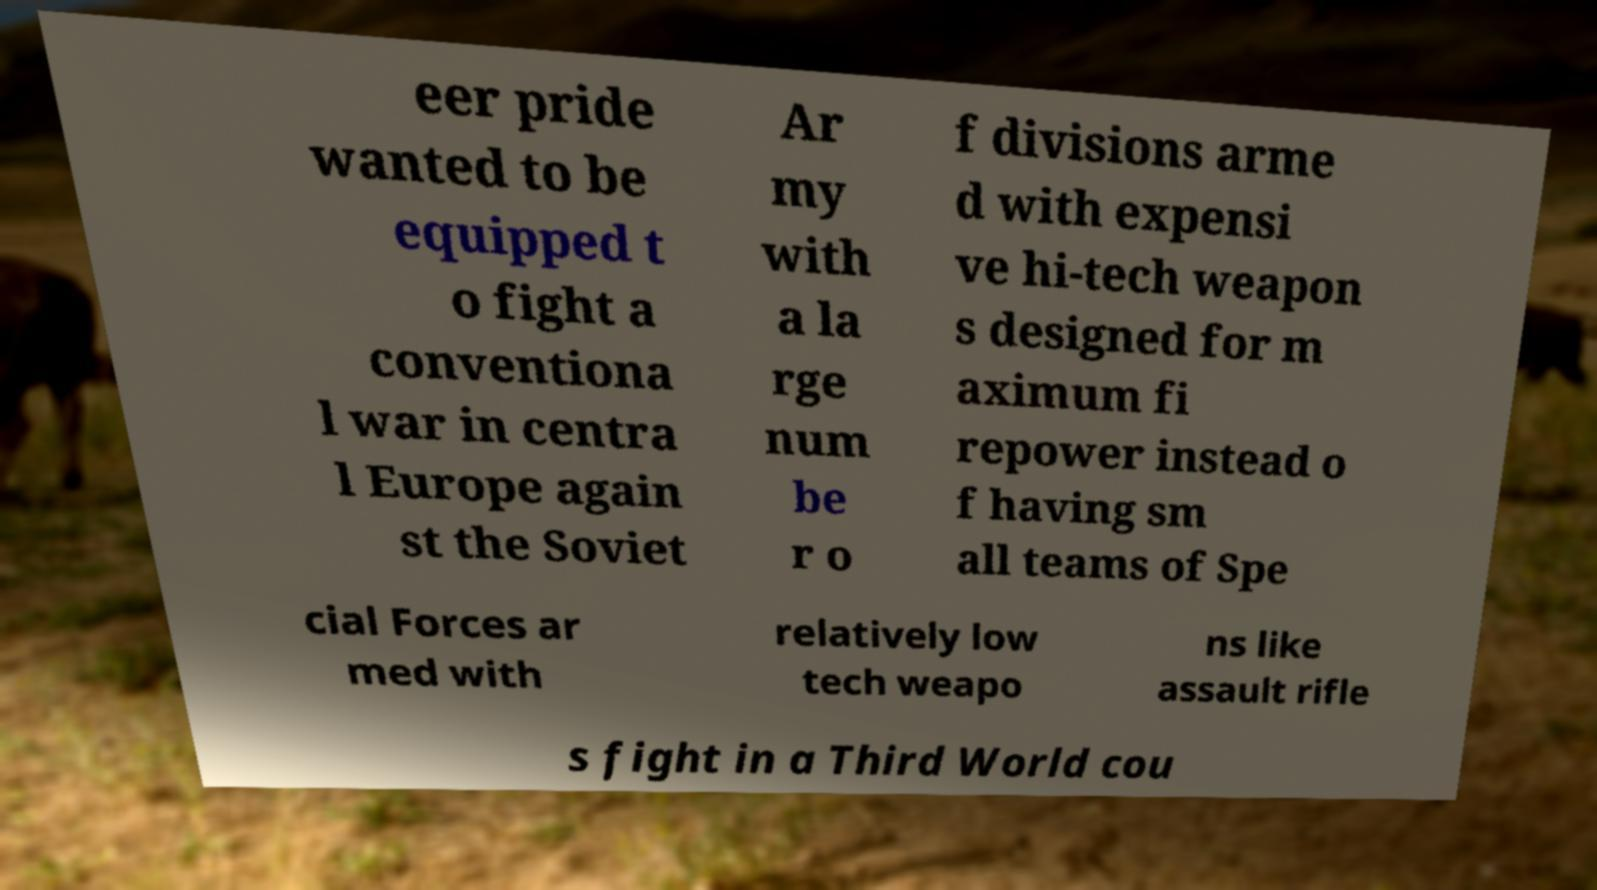Please identify and transcribe the text found in this image. eer pride wanted to be equipped t o fight a conventiona l war in centra l Europe again st the Soviet Ar my with a la rge num be r o f divisions arme d with expensi ve hi-tech weapon s designed for m aximum fi repower instead o f having sm all teams of Spe cial Forces ar med with relatively low tech weapo ns like assault rifle s fight in a Third World cou 